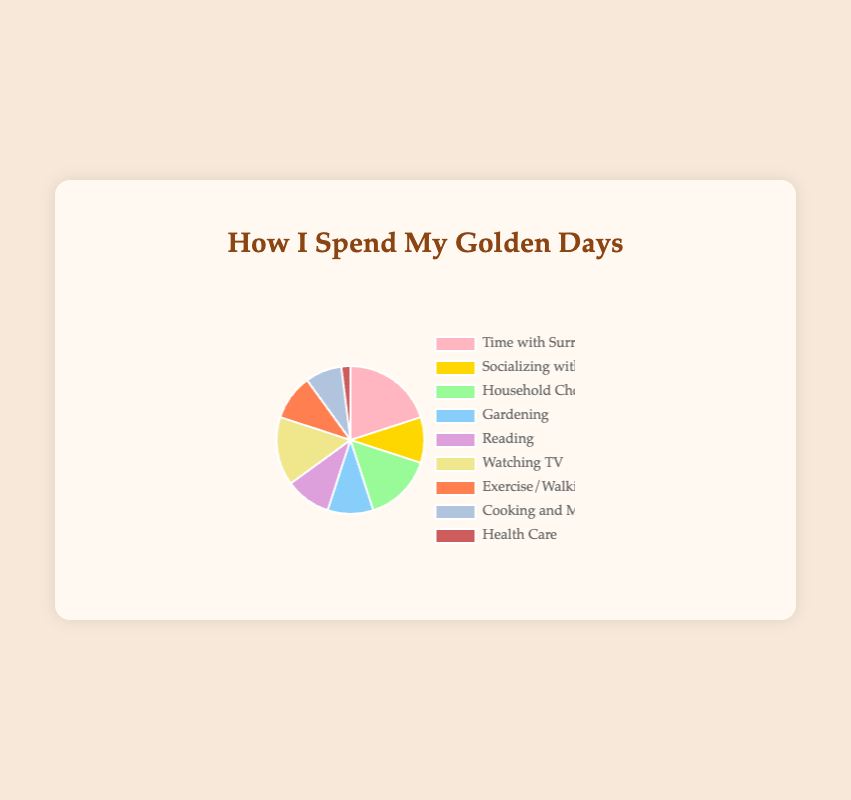What activity do elderly widows spend the most time on? To find the activity with the highest percentage, simply look for the largest segment in the pie chart. "Spending Time with Surrogate Grandchild" represents 20% which is the highest percentage.
Answer: Spending Time with Surrogate Grandchild Which two activities have the same percentage of time spent? By comparing the segments in the pie chart, you can see that "Socializing with Friends," "Gardening," "Reading," and "Exercise/Walking" all spend 10% of their time. Any pair among these activities would answer the question.
Answer: Socializing with Friends and Gardening (or other pairs like Reading and Exercise/Walking) How much more time is spent Watching TV than on Cooking and Meals? Watching TV accounts for 15%, while Cooking and Meals account for 8%. The difference is calculated as 15% - 8%.
Answer: 7% What is the sum of the percentages for Household Chores and Gardening? Household Chores account for 15% and Gardening accounts for 10%. Adding them together, 15% + 10% = 25%.
Answer: 25% Which activity is represented by the green segment? The green segment corresponds to "Household Chores."
Answer: Household Chores How much time is spent on activities other than Spending Time with Surrogate Grandchild? Subtract the percentage of time spent on "Spending Time with Surrogate Grandchild" from 100%. That is 100% - 20% = 80%.
Answer: 80% Which activities take up more percentage of the day than Exercise/Walking? Exercise/Walking is 10%. The activities with a higher percentage are "Spending Time with Surrogate Grandchild" (20%), "Household Chores" (15%), and "Watching TV" (15%).
Answer: Spending Time with Surrogate Grandchild, Household Chores, Watching TV Which activity is represented by the purple segment? The purple segment corresponds to "Reading."
Answer: Reading How much time is spent on Health Care activities combined with Cooking and Meals? Health Care is 2% and Cooking and Meals is 8%. Adding them together, 2% + 8% = 10%.
Answer: 10% 